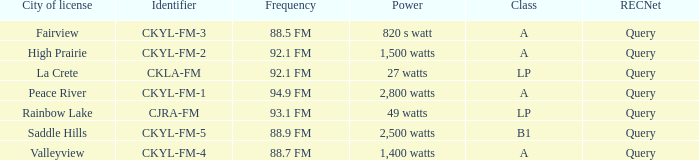In which licensed city is there a 1,400 watts power? Valleyview. 